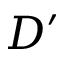<formula> <loc_0><loc_0><loc_500><loc_500>D ^ { \prime }</formula> 